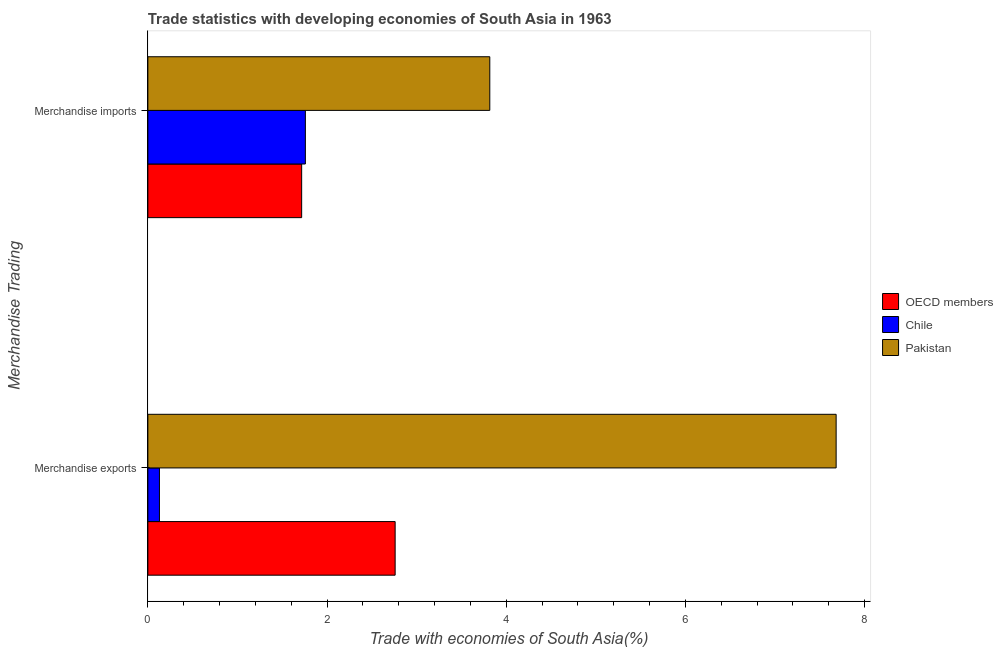How many groups of bars are there?
Make the answer very short. 2. Are the number of bars per tick equal to the number of legend labels?
Your answer should be very brief. Yes. Are the number of bars on each tick of the Y-axis equal?
Your response must be concise. Yes. What is the merchandise imports in OECD members?
Give a very brief answer. 1.72. Across all countries, what is the maximum merchandise imports?
Your response must be concise. 3.82. Across all countries, what is the minimum merchandise imports?
Keep it short and to the point. 1.72. In which country was the merchandise imports maximum?
Provide a short and direct response. Pakistan. In which country was the merchandise exports minimum?
Your answer should be very brief. Chile. What is the total merchandise imports in the graph?
Make the answer very short. 7.29. What is the difference between the merchandise exports in Chile and that in Pakistan?
Make the answer very short. -7.55. What is the difference between the merchandise imports in Pakistan and the merchandise exports in OECD members?
Your answer should be compact. 1.06. What is the average merchandise imports per country?
Provide a succinct answer. 2.43. What is the difference between the merchandise exports and merchandise imports in OECD members?
Ensure brevity in your answer.  1.04. In how many countries, is the merchandise imports greater than 7.2 %?
Your answer should be very brief. 0. What is the ratio of the merchandise imports in OECD members to that in Pakistan?
Offer a terse response. 0.45. Is the merchandise exports in Pakistan less than that in OECD members?
Provide a short and direct response. No. In how many countries, is the merchandise imports greater than the average merchandise imports taken over all countries?
Make the answer very short. 1. What does the 3rd bar from the bottom in Merchandise imports represents?
Give a very brief answer. Pakistan. How many bars are there?
Your answer should be compact. 6. How many countries are there in the graph?
Ensure brevity in your answer.  3. Are the values on the major ticks of X-axis written in scientific E-notation?
Provide a succinct answer. No. Does the graph contain any zero values?
Offer a terse response. No. Where does the legend appear in the graph?
Your answer should be very brief. Center right. How are the legend labels stacked?
Offer a very short reply. Vertical. What is the title of the graph?
Your answer should be compact. Trade statistics with developing economies of South Asia in 1963. What is the label or title of the X-axis?
Make the answer very short. Trade with economies of South Asia(%). What is the label or title of the Y-axis?
Your response must be concise. Merchandise Trading. What is the Trade with economies of South Asia(%) of OECD members in Merchandise exports?
Your answer should be very brief. 2.76. What is the Trade with economies of South Asia(%) of Chile in Merchandise exports?
Offer a terse response. 0.13. What is the Trade with economies of South Asia(%) in Pakistan in Merchandise exports?
Give a very brief answer. 7.68. What is the Trade with economies of South Asia(%) of OECD members in Merchandise imports?
Give a very brief answer. 1.72. What is the Trade with economies of South Asia(%) in Chile in Merchandise imports?
Your answer should be very brief. 1.76. What is the Trade with economies of South Asia(%) of Pakistan in Merchandise imports?
Your answer should be very brief. 3.82. Across all Merchandise Trading, what is the maximum Trade with economies of South Asia(%) in OECD members?
Keep it short and to the point. 2.76. Across all Merchandise Trading, what is the maximum Trade with economies of South Asia(%) in Chile?
Your answer should be very brief. 1.76. Across all Merchandise Trading, what is the maximum Trade with economies of South Asia(%) of Pakistan?
Provide a short and direct response. 7.68. Across all Merchandise Trading, what is the minimum Trade with economies of South Asia(%) in OECD members?
Keep it short and to the point. 1.72. Across all Merchandise Trading, what is the minimum Trade with economies of South Asia(%) of Chile?
Offer a very short reply. 0.13. Across all Merchandise Trading, what is the minimum Trade with economies of South Asia(%) in Pakistan?
Keep it short and to the point. 3.82. What is the total Trade with economies of South Asia(%) of OECD members in the graph?
Offer a very short reply. 4.48. What is the total Trade with economies of South Asia(%) in Chile in the graph?
Offer a very short reply. 1.89. What is the total Trade with economies of South Asia(%) of Pakistan in the graph?
Offer a terse response. 11.5. What is the difference between the Trade with economies of South Asia(%) of OECD members in Merchandise exports and that in Merchandise imports?
Give a very brief answer. 1.04. What is the difference between the Trade with economies of South Asia(%) in Chile in Merchandise exports and that in Merchandise imports?
Provide a short and direct response. -1.63. What is the difference between the Trade with economies of South Asia(%) in Pakistan in Merchandise exports and that in Merchandise imports?
Provide a succinct answer. 3.87. What is the difference between the Trade with economies of South Asia(%) of OECD members in Merchandise exports and the Trade with economies of South Asia(%) of Chile in Merchandise imports?
Your answer should be very brief. 1. What is the difference between the Trade with economies of South Asia(%) of OECD members in Merchandise exports and the Trade with economies of South Asia(%) of Pakistan in Merchandise imports?
Provide a short and direct response. -1.06. What is the difference between the Trade with economies of South Asia(%) in Chile in Merchandise exports and the Trade with economies of South Asia(%) in Pakistan in Merchandise imports?
Keep it short and to the point. -3.69. What is the average Trade with economies of South Asia(%) in OECD members per Merchandise Trading?
Ensure brevity in your answer.  2.24. What is the average Trade with economies of South Asia(%) in Chile per Merchandise Trading?
Make the answer very short. 0.94. What is the average Trade with economies of South Asia(%) in Pakistan per Merchandise Trading?
Your answer should be compact. 5.75. What is the difference between the Trade with economies of South Asia(%) of OECD members and Trade with economies of South Asia(%) of Chile in Merchandise exports?
Keep it short and to the point. 2.63. What is the difference between the Trade with economies of South Asia(%) in OECD members and Trade with economies of South Asia(%) in Pakistan in Merchandise exports?
Make the answer very short. -4.92. What is the difference between the Trade with economies of South Asia(%) of Chile and Trade with economies of South Asia(%) of Pakistan in Merchandise exports?
Keep it short and to the point. -7.55. What is the difference between the Trade with economies of South Asia(%) of OECD members and Trade with economies of South Asia(%) of Chile in Merchandise imports?
Provide a short and direct response. -0.04. What is the difference between the Trade with economies of South Asia(%) of OECD members and Trade with economies of South Asia(%) of Pakistan in Merchandise imports?
Make the answer very short. -2.1. What is the difference between the Trade with economies of South Asia(%) of Chile and Trade with economies of South Asia(%) of Pakistan in Merchandise imports?
Your answer should be compact. -2.06. What is the ratio of the Trade with economies of South Asia(%) of OECD members in Merchandise exports to that in Merchandise imports?
Give a very brief answer. 1.61. What is the ratio of the Trade with economies of South Asia(%) of Chile in Merchandise exports to that in Merchandise imports?
Your answer should be very brief. 0.07. What is the ratio of the Trade with economies of South Asia(%) of Pakistan in Merchandise exports to that in Merchandise imports?
Your answer should be compact. 2.01. What is the difference between the highest and the second highest Trade with economies of South Asia(%) of OECD members?
Keep it short and to the point. 1.04. What is the difference between the highest and the second highest Trade with economies of South Asia(%) of Chile?
Keep it short and to the point. 1.63. What is the difference between the highest and the second highest Trade with economies of South Asia(%) of Pakistan?
Provide a succinct answer. 3.87. What is the difference between the highest and the lowest Trade with economies of South Asia(%) in OECD members?
Your response must be concise. 1.04. What is the difference between the highest and the lowest Trade with economies of South Asia(%) of Chile?
Your response must be concise. 1.63. What is the difference between the highest and the lowest Trade with economies of South Asia(%) of Pakistan?
Your response must be concise. 3.87. 